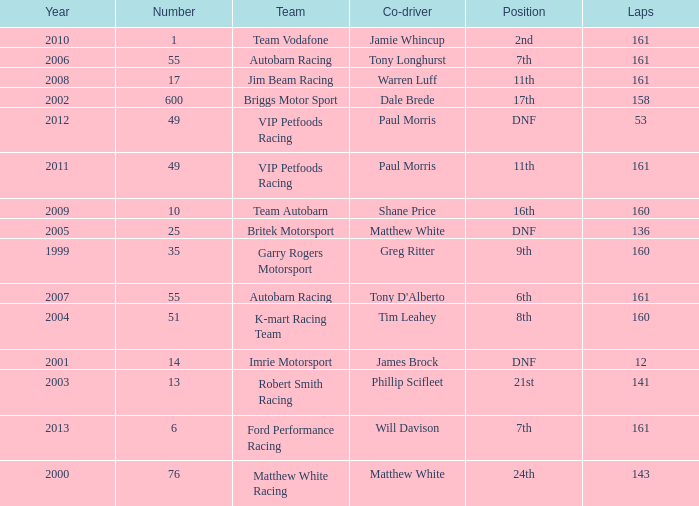Who was the co-driver for the team with more than 160 laps and the number 6 after 2010? Will Davison. 